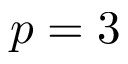Convert formula to latex. <formula><loc_0><loc_0><loc_500><loc_500>p = 3</formula> 